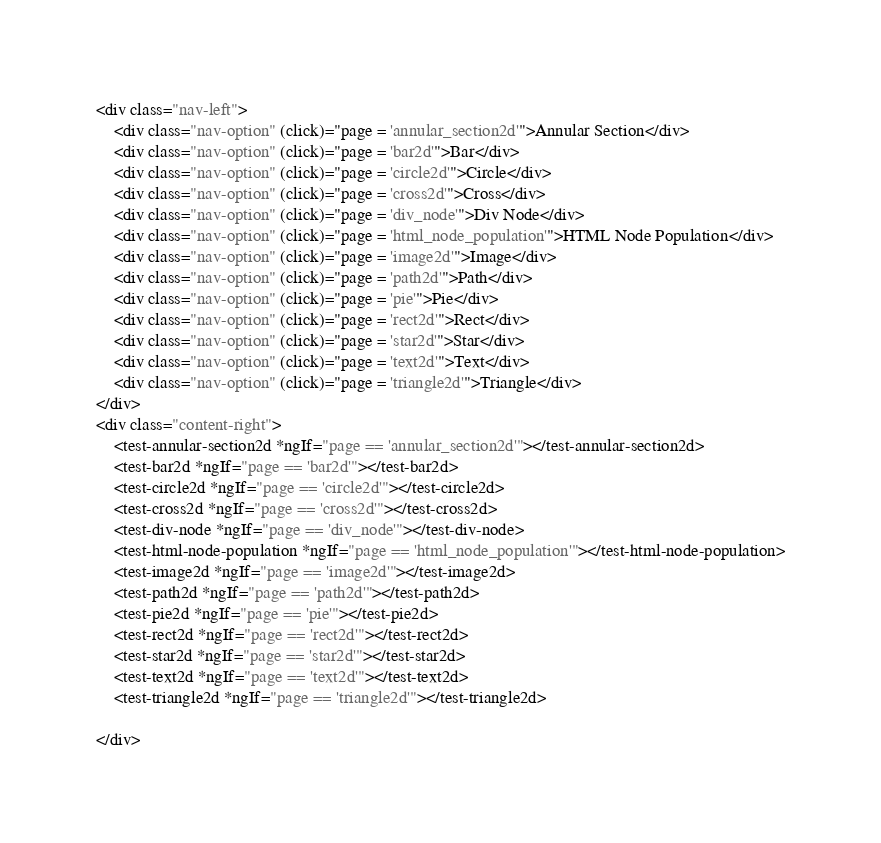<code> <loc_0><loc_0><loc_500><loc_500><_HTML_><div class="nav-left">
    <div class="nav-option" (click)="page = 'annular_section2d'">Annular Section</div>
    <div class="nav-option" (click)="page = 'bar2d'">Bar</div>
    <div class="nav-option" (click)="page = 'circle2d'">Circle</div>
    <div class="nav-option" (click)="page = 'cross2d'">Cross</div>
    <div class="nav-option" (click)="page = 'div_node'">Div Node</div>
    <div class="nav-option" (click)="page = 'html_node_population'">HTML Node Population</div>
    <div class="nav-option" (click)="page = 'image2d'">Image</div>
    <div class="nav-option" (click)="page = 'path2d'">Path</div>
    <div class="nav-option" (click)="page = 'pie'">Pie</div>
    <div class="nav-option" (click)="page = 'rect2d'">Rect</div>
    <div class="nav-option" (click)="page = 'star2d'">Star</div>
    <div class="nav-option" (click)="page = 'text2d'">Text</div>
    <div class="nav-option" (click)="page = 'triangle2d'">Triangle</div>
</div>
<div class="content-right">
    <test-annular-section2d *ngIf="page == 'annular_section2d'"></test-annular-section2d>
    <test-bar2d *ngIf="page == 'bar2d'"></test-bar2d>
    <test-circle2d *ngIf="page == 'circle2d'"></test-circle2d>
    <test-cross2d *ngIf="page == 'cross2d'"></test-cross2d>
    <test-div-node *ngIf="page == 'div_node'"></test-div-node>
    <test-html-node-population *ngIf="page == 'html_node_population'"></test-html-node-population>
    <test-image2d *ngIf="page == 'image2d'"></test-image2d>
    <test-path2d *ngIf="page == 'path2d'"></test-path2d>
    <test-pie2d *ngIf="page == 'pie'"></test-pie2d>
    <test-rect2d *ngIf="page == 'rect2d'"></test-rect2d>
    <test-star2d *ngIf="page == 'star2d'"></test-star2d>
    <test-text2d *ngIf="page == 'text2d'"></test-text2d>
    <test-triangle2d *ngIf="page == 'triangle2d'"></test-triangle2d>

</div></code> 